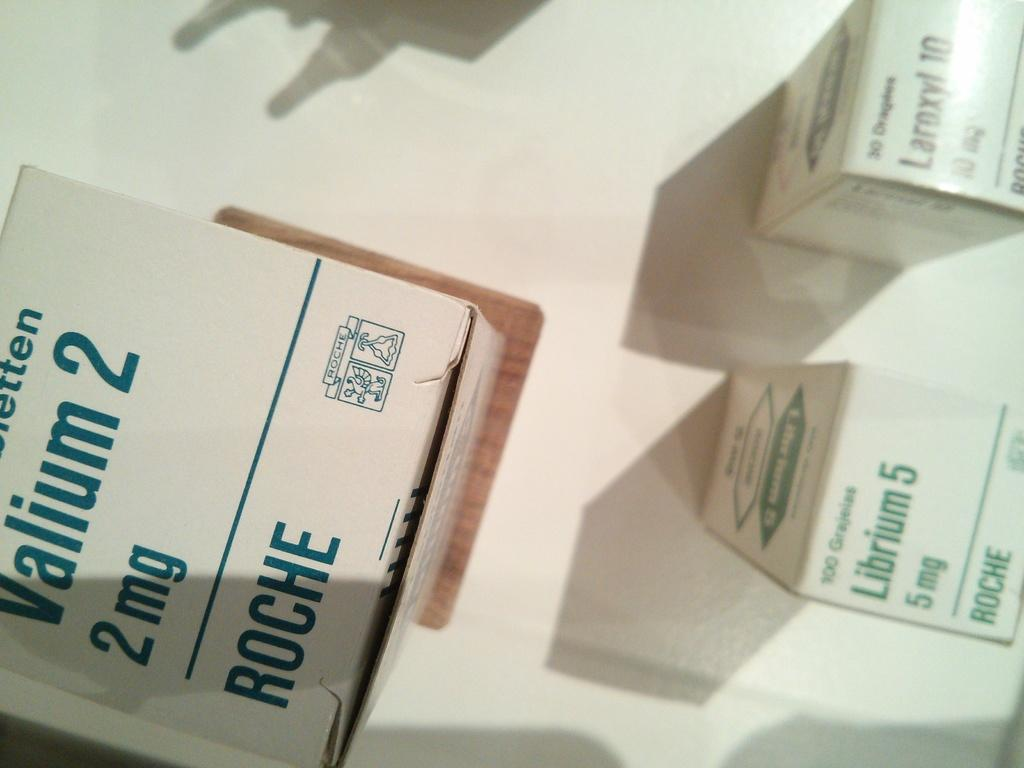Provide a one-sentence caption for the provided image. Medical supplies include Valium 2 and Librium 5. 